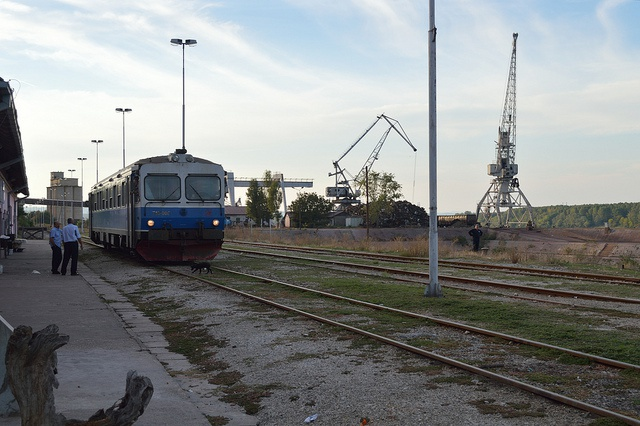Describe the objects in this image and their specific colors. I can see train in white, black, gray, navy, and blue tones, people in white, black, gray, and darkblue tones, people in white, black, darkblue, gray, and navy tones, and people in white, black, and gray tones in this image. 